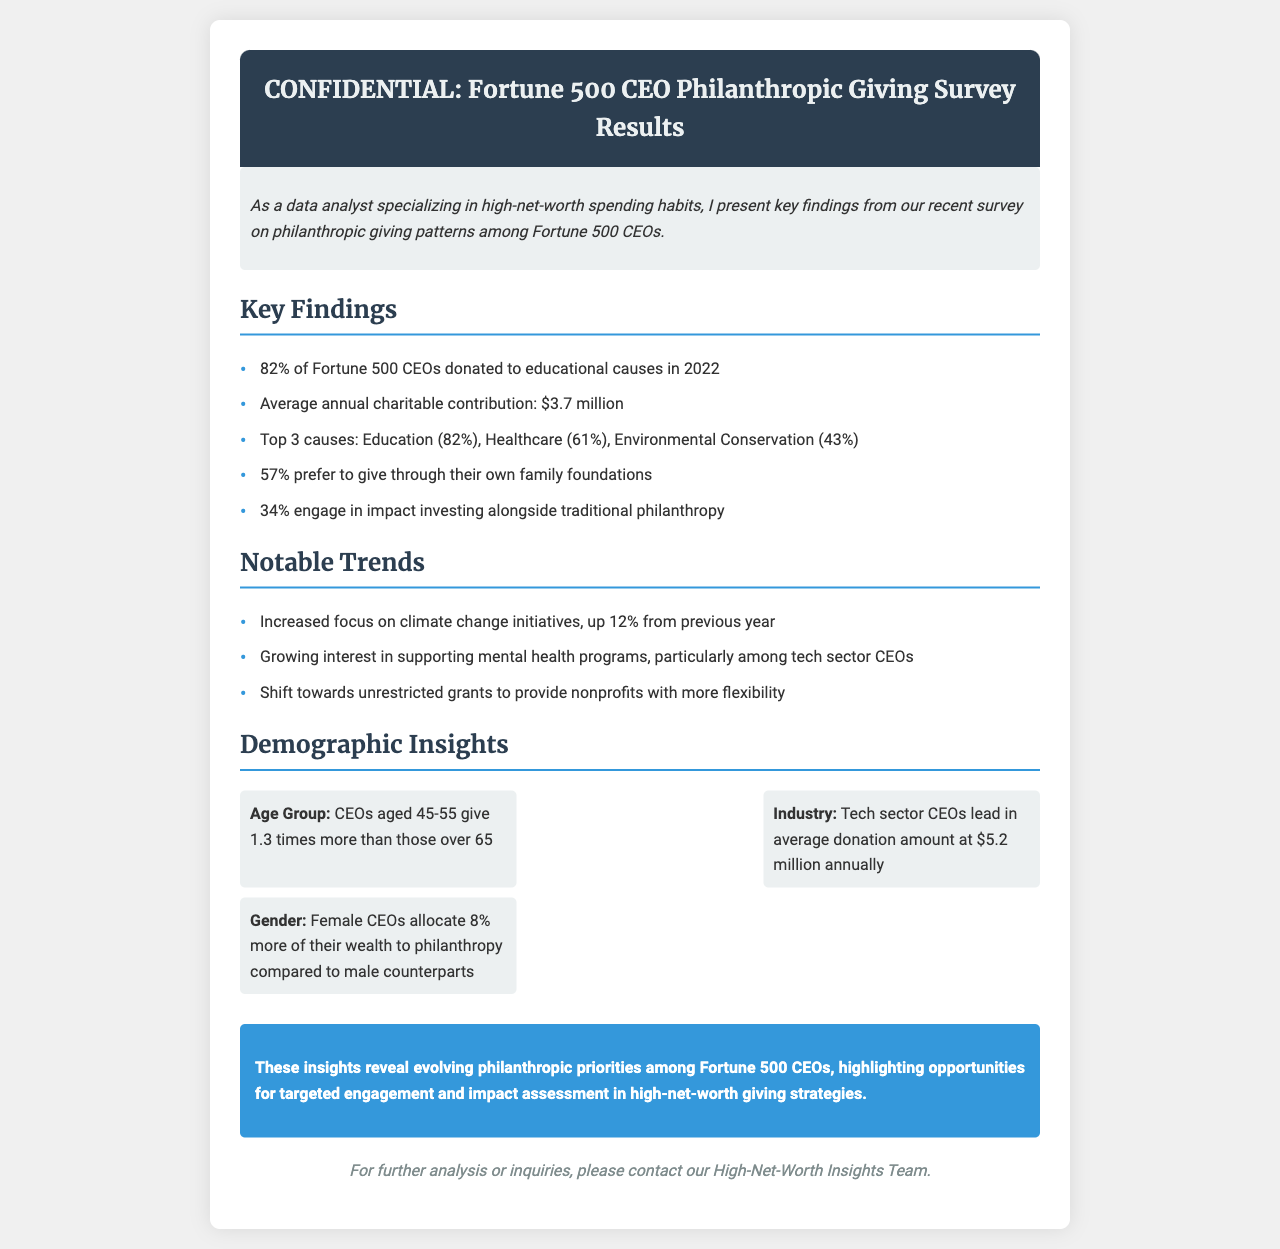what percentage of CEOs donated to educational causes in 2022? The document states that 82% of Fortune 500 CEOs donated to educational causes in 2022.
Answer: 82% what was the average annual charitable contribution? The average annual charitable contribution according to the survey results is $3.7 million.
Answer: $3.7 million which cause received the highest percentage of donations? The document indicates that Education is the top cause with 82% of donations.
Answer: Education what is the average donation amount by tech sector CEOs? The document mentions that tech sector CEOs have an average donation amount of $5.2 million annually.
Answer: $5.2 million how much more do female CEOs allocate to philanthropy compared to male CEOs? The document states that female CEOs allocate 8% more of their wealth to philanthropy compared to male counterparts.
Answer: 8% what trend saw a 12% increase from the previous year? The document notes an increased focus on climate change initiatives, which is up 12% from the previous year.
Answer: climate change initiatives what type of grants are becoming more popular among Fortune 500 CEOs? The document highlights a shift towards unrestricted grants to provide nonprofits with more flexibility.
Answer: unrestricted grants which age group of CEOs donates more? The document explains that CEOs aged 45-55 give 1.3 times more than those over 65.
Answer: 45-55 how do the findings inform high-net-worth giving strategies? The conclusion suggests that insights reveal evolving philanthropic priorities among CEOs, indicating opportunities for targeted engagement.
Answer: targeted engagement 